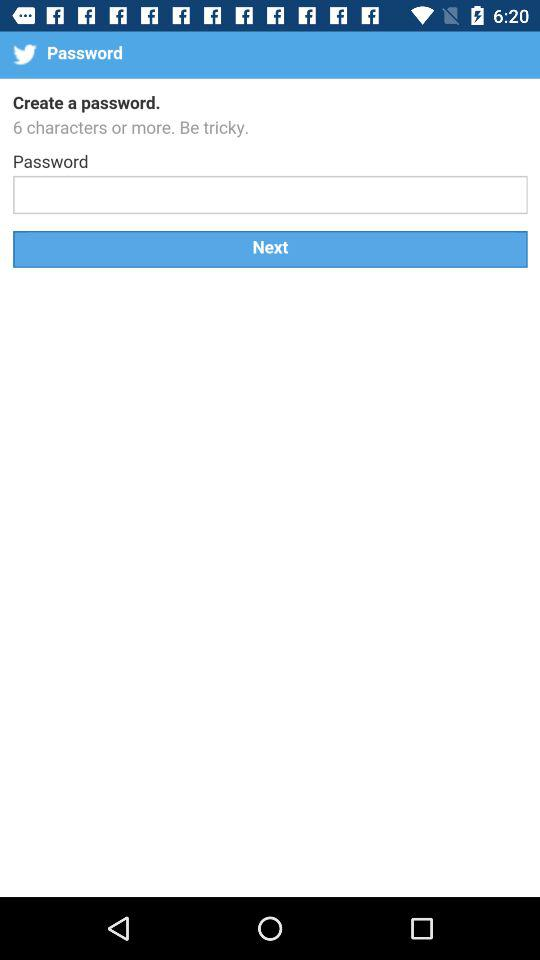How often does the password need to be renewed?
When the provided information is insufficient, respond with <no answer>. <no answer> 